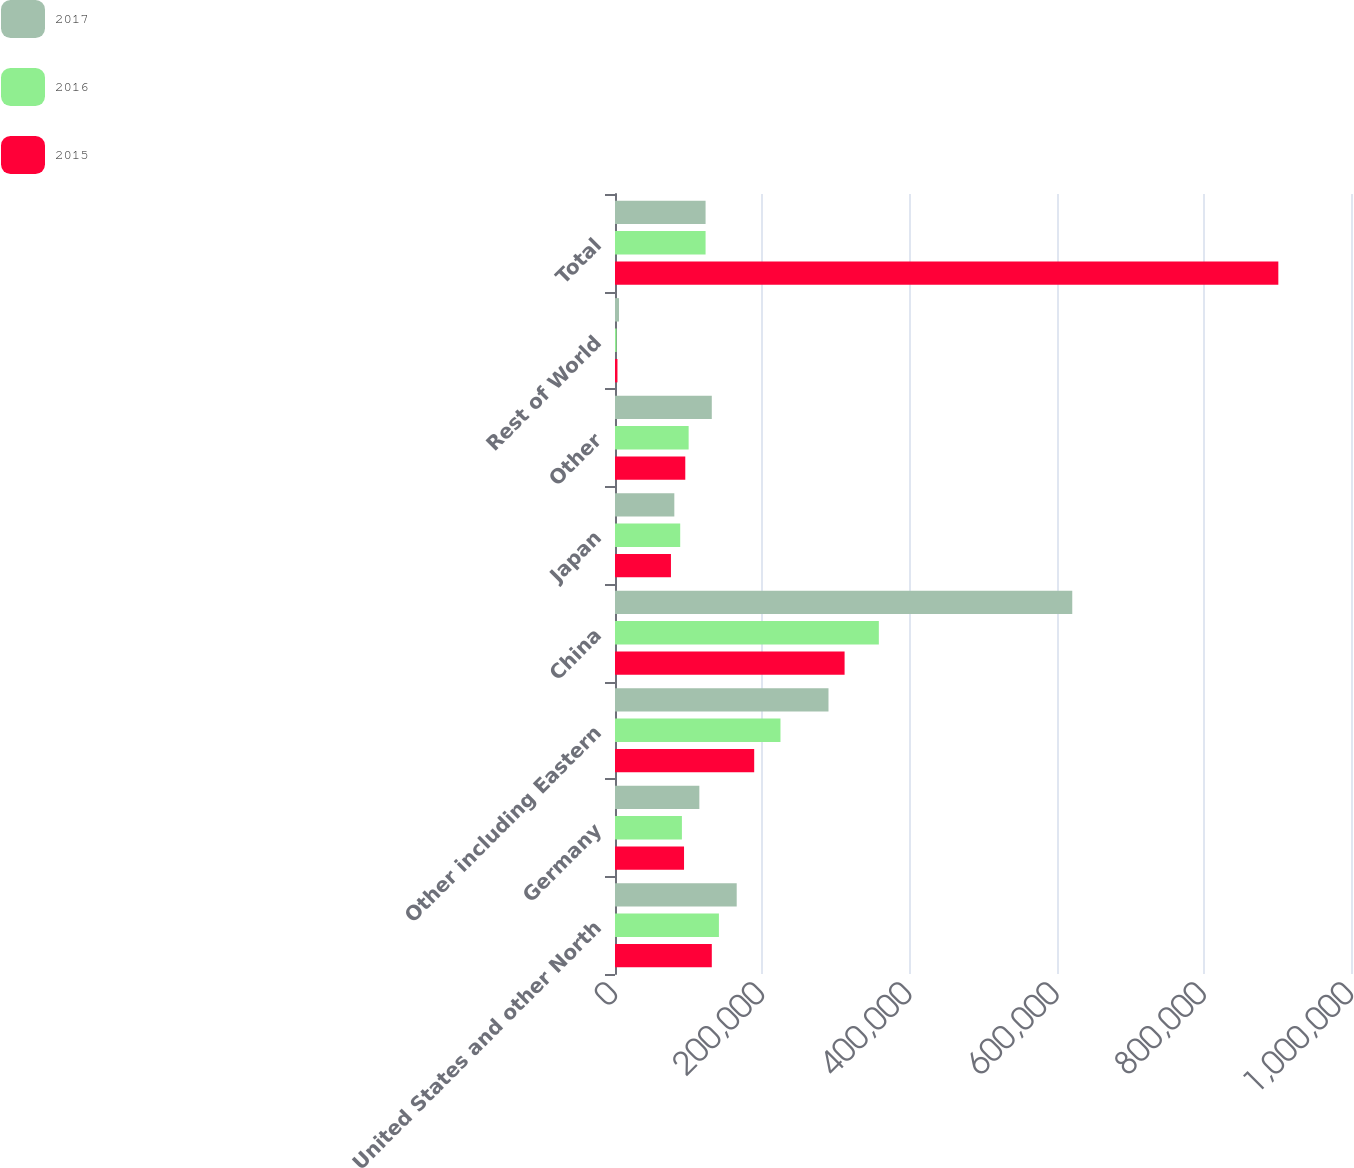<chart> <loc_0><loc_0><loc_500><loc_500><stacked_bar_chart><ecel><fcel>United States and other North<fcel>Germany<fcel>Other including Eastern<fcel>China<fcel>Japan<fcel>Other<fcel>Rest of World<fcel>Total<nl><fcel>2017<fcel>165363<fcel>114608<fcel>290067<fcel>621283<fcel>80612<fcel>131511<fcel>5445<fcel>123060<nl><fcel>2016<fcel>141184<fcel>90893<fcel>224836<fcel>358476<fcel>88592<fcel>100052<fcel>2140<fcel>123060<nl><fcel>2015<fcel>131525<fcel>93802<fcel>189123<fcel>311946<fcel>76033<fcel>95494<fcel>3342<fcel>901265<nl></chart> 